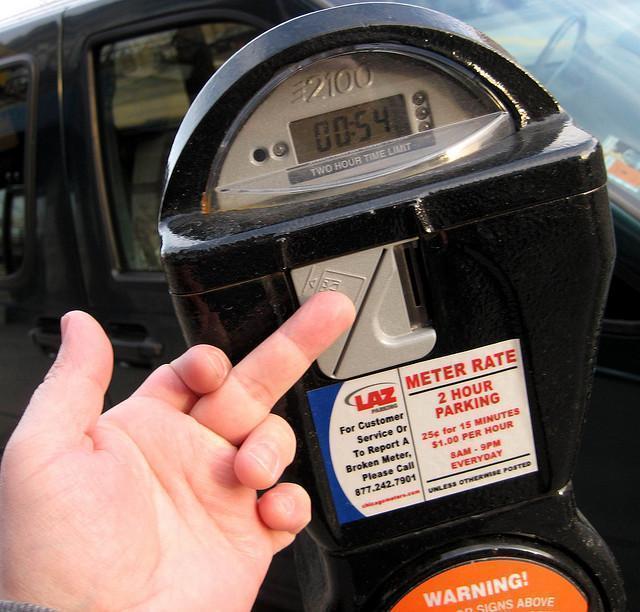What are they doing?
Make your selection from the four choices given to correctly answer the question.
Options: Attacking meter, paying meter, reading meter, expressing displeasure. Expressing displeasure. 